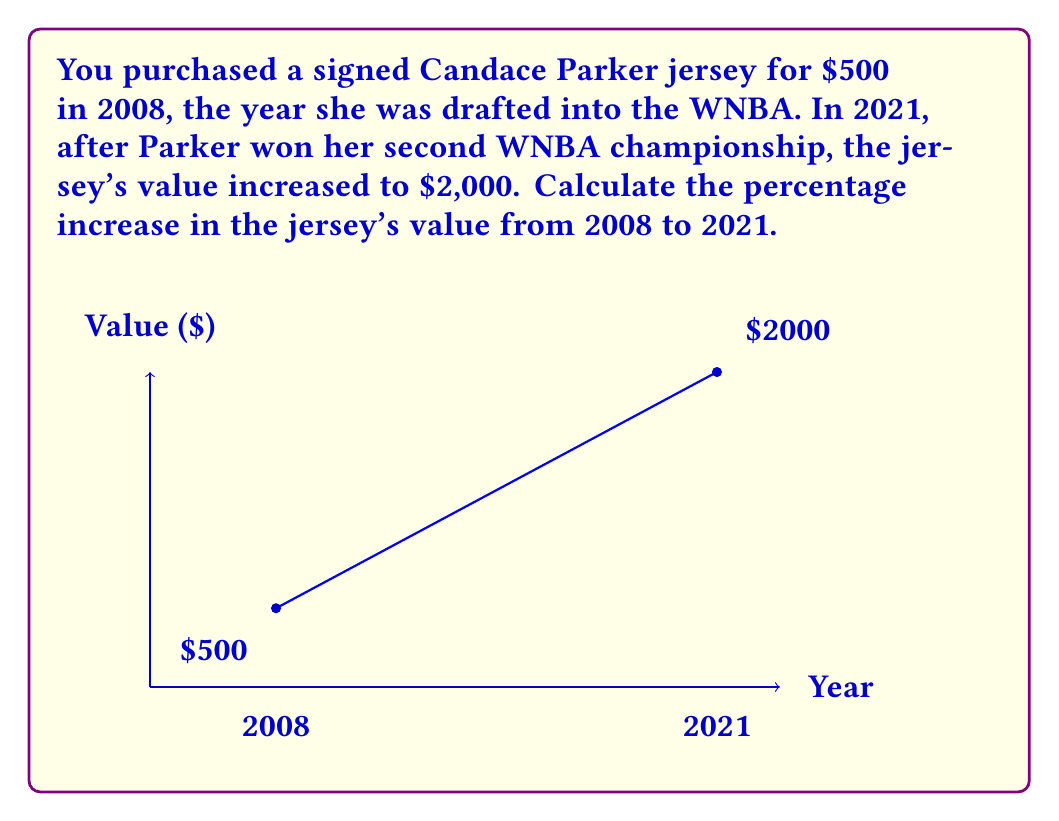Teach me how to tackle this problem. To calculate the percentage increase, we'll use the formula:

$$ \text{Percentage Increase} = \frac{\text{Increase in Value}}{\text{Original Value}} \times 100\% $$

Step 1: Calculate the increase in value
$$ \text{Increase} = \text{Final Value} - \text{Original Value} $$
$$ \text{Increase} = \$2000 - \$500 = \$1500 $$

Step 2: Divide the increase by the original value
$$ \frac{\text{Increase}}{\text{Original Value}} = \frac{\$1500}{\$500} = 3 $$

Step 3: Convert to a percentage by multiplying by 100%
$$ \text{Percentage Increase} = 3 \times 100\% = 300\% $$

Therefore, the signed Candace Parker jersey increased in value by 300% from 2008 to 2021.
Answer: 300% 